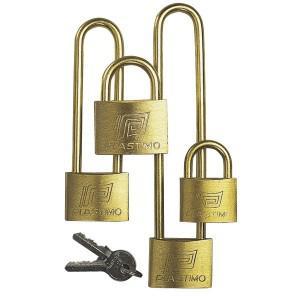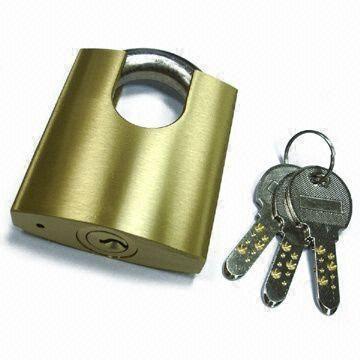The first image is the image on the left, the second image is the image on the right. For the images displayed, is the sentence "There are at least 3 keys present, next to locks." factually correct? Answer yes or no. Yes. The first image is the image on the left, the second image is the image on the right. Examine the images to the left and right. Is the description "In one image of each pair there is a keyhole on the front of the lock." accurate? Answer yes or no. No. 